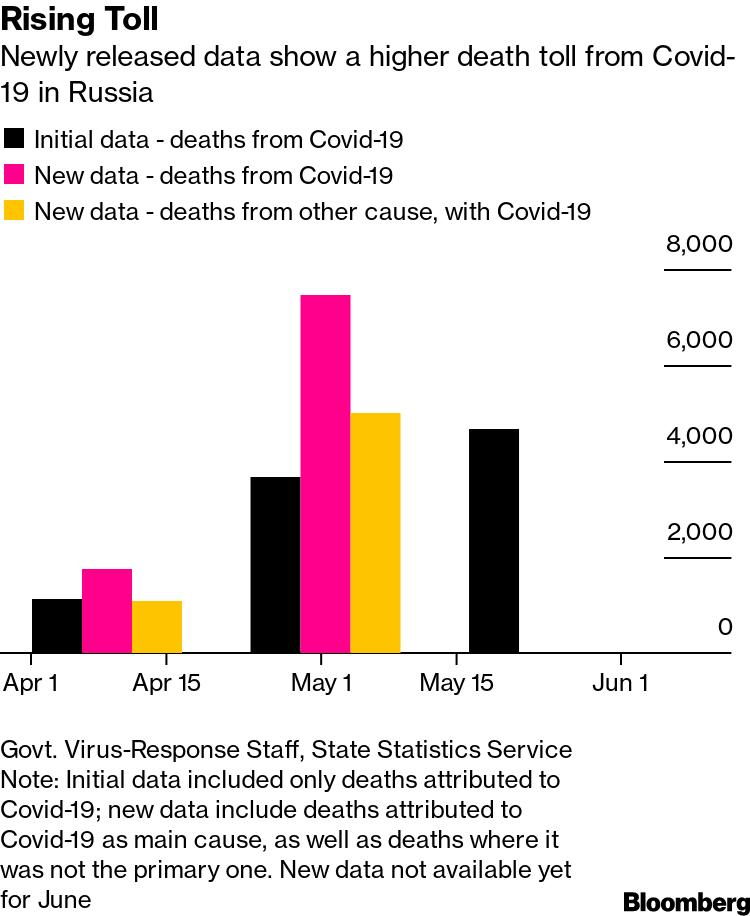List a handful of essential elements in this visual. There are three months mentioned in the graph. 